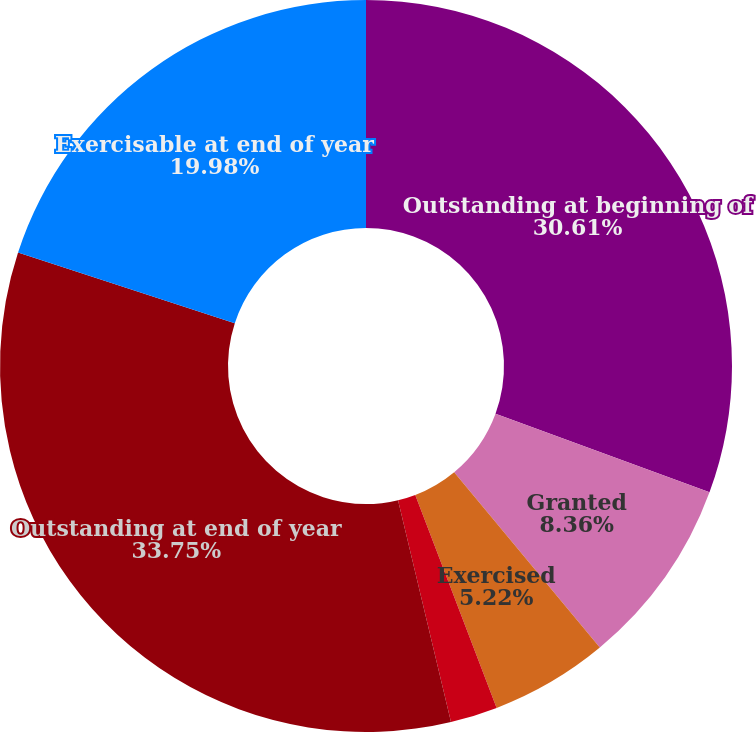Convert chart to OTSL. <chart><loc_0><loc_0><loc_500><loc_500><pie_chart><fcel>Outstanding at beginning of<fcel>Granted<fcel>Exercised<fcel>Expired or canceled<fcel>Outstanding at end of year<fcel>Exercisable at end of year<nl><fcel>30.61%<fcel>8.36%<fcel>5.22%<fcel>2.08%<fcel>33.75%<fcel>19.98%<nl></chart> 